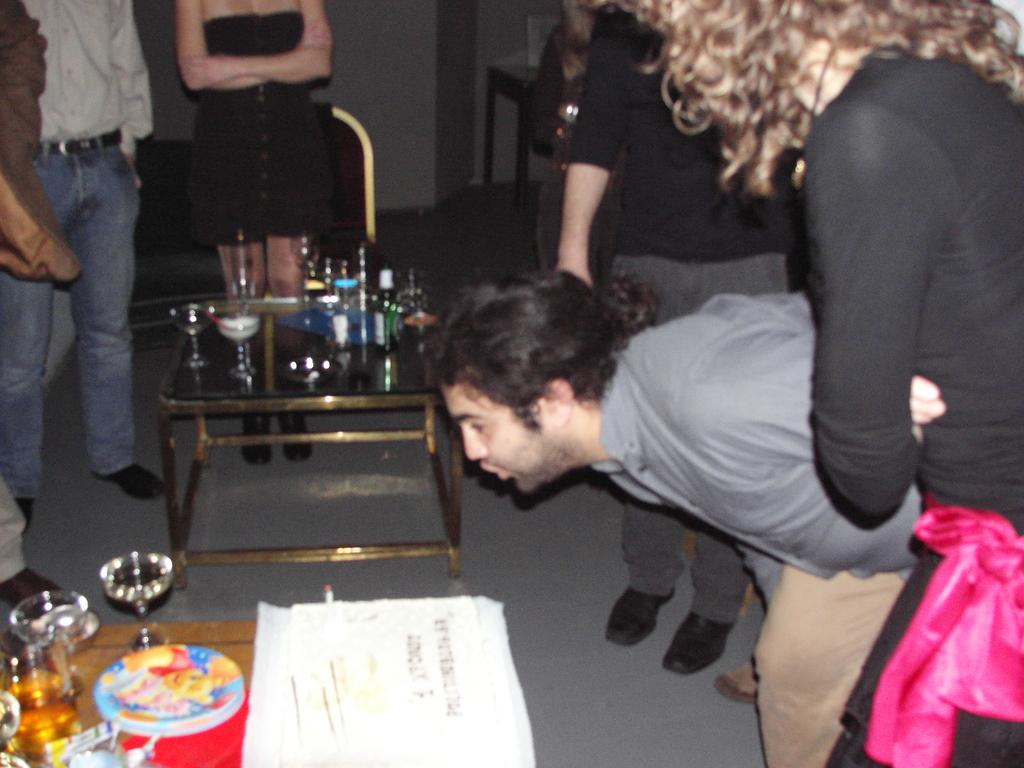What are the people near in the image? The people are standing near a table in the image. What objects can be seen on the table? There are bottles and glasses on the table in the image. How many oranges are on the table in the image? There are no oranges present on the table in the image. What type of sponge can be seen cleaning the glasses in the image? There is no sponge visible in the image, and the glasses are not being cleaned. 